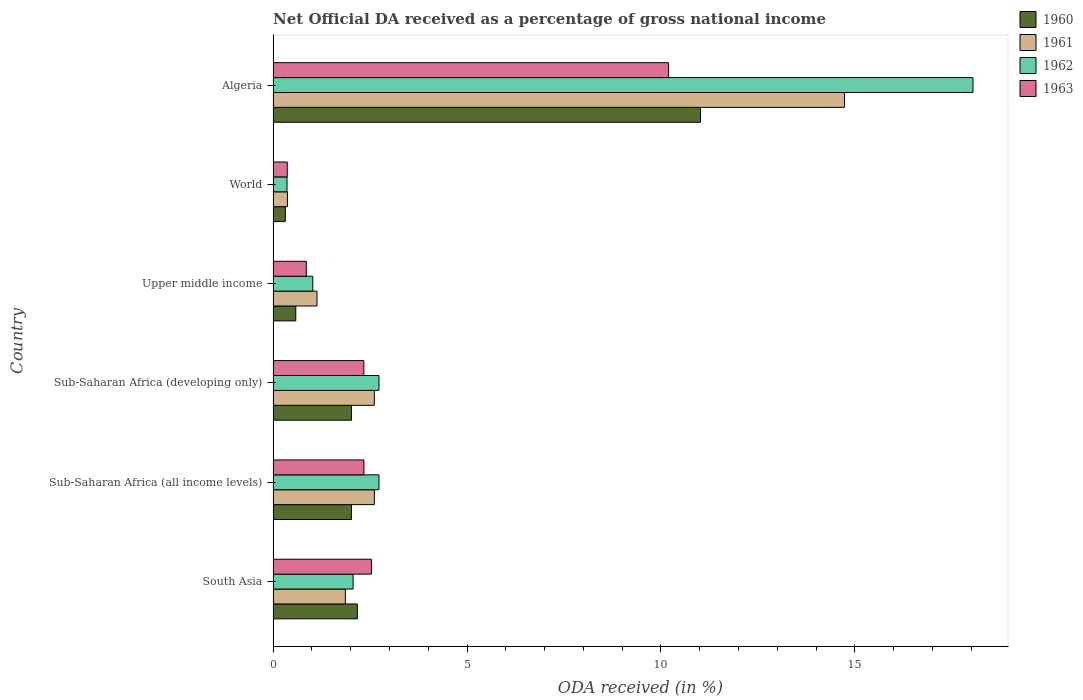Are the number of bars per tick equal to the number of legend labels?
Give a very brief answer. Yes. What is the label of the 2nd group of bars from the top?
Your response must be concise. World. What is the net official DA received in 1960 in World?
Your response must be concise. 0.31. Across all countries, what is the maximum net official DA received in 1961?
Ensure brevity in your answer.  14.73. Across all countries, what is the minimum net official DA received in 1961?
Give a very brief answer. 0.37. In which country was the net official DA received in 1960 maximum?
Give a very brief answer. Algeria. What is the total net official DA received in 1960 in the graph?
Your answer should be very brief. 18.13. What is the difference between the net official DA received in 1960 in Sub-Saharan Africa (developing only) and that in World?
Offer a very short reply. 1.71. What is the difference between the net official DA received in 1962 in World and the net official DA received in 1961 in Upper middle income?
Provide a short and direct response. -0.77. What is the average net official DA received in 1963 per country?
Offer a terse response. 3.11. What is the difference between the net official DA received in 1960 and net official DA received in 1963 in Upper middle income?
Make the answer very short. -0.27. What is the ratio of the net official DA received in 1963 in Algeria to that in World?
Your answer should be compact. 27.96. Is the difference between the net official DA received in 1960 in South Asia and World greater than the difference between the net official DA received in 1963 in South Asia and World?
Your answer should be compact. No. What is the difference between the highest and the second highest net official DA received in 1960?
Your answer should be very brief. 8.85. What is the difference between the highest and the lowest net official DA received in 1961?
Your answer should be very brief. 14.36. Is the sum of the net official DA received in 1962 in Algeria and Upper middle income greater than the maximum net official DA received in 1960 across all countries?
Offer a terse response. Yes. Is it the case that in every country, the sum of the net official DA received in 1961 and net official DA received in 1963 is greater than the sum of net official DA received in 1960 and net official DA received in 1962?
Give a very brief answer. No. What does the 4th bar from the top in Upper middle income represents?
Keep it short and to the point. 1960. Is it the case that in every country, the sum of the net official DA received in 1961 and net official DA received in 1962 is greater than the net official DA received in 1963?
Give a very brief answer. Yes. Are the values on the major ticks of X-axis written in scientific E-notation?
Your response must be concise. No. Does the graph contain any zero values?
Keep it short and to the point. No. Does the graph contain grids?
Offer a very short reply. No. Where does the legend appear in the graph?
Your answer should be very brief. Top right. What is the title of the graph?
Your response must be concise. Net Official DA received as a percentage of gross national income. Does "1970" appear as one of the legend labels in the graph?
Keep it short and to the point. No. What is the label or title of the X-axis?
Make the answer very short. ODA received (in %). What is the label or title of the Y-axis?
Your answer should be very brief. Country. What is the ODA received (in %) in 1960 in South Asia?
Your answer should be very brief. 2.17. What is the ODA received (in %) of 1961 in South Asia?
Your response must be concise. 1.86. What is the ODA received (in %) in 1962 in South Asia?
Your response must be concise. 2.06. What is the ODA received (in %) of 1963 in South Asia?
Keep it short and to the point. 2.53. What is the ODA received (in %) of 1960 in Sub-Saharan Africa (all income levels)?
Your answer should be compact. 2.02. What is the ODA received (in %) of 1961 in Sub-Saharan Africa (all income levels)?
Provide a succinct answer. 2.61. What is the ODA received (in %) of 1962 in Sub-Saharan Africa (all income levels)?
Keep it short and to the point. 2.73. What is the ODA received (in %) of 1963 in Sub-Saharan Africa (all income levels)?
Your response must be concise. 2.34. What is the ODA received (in %) of 1960 in Sub-Saharan Africa (developing only)?
Make the answer very short. 2.02. What is the ODA received (in %) of 1961 in Sub-Saharan Africa (developing only)?
Make the answer very short. 2.61. What is the ODA received (in %) in 1962 in Sub-Saharan Africa (developing only)?
Your response must be concise. 2.73. What is the ODA received (in %) in 1963 in Sub-Saharan Africa (developing only)?
Your answer should be very brief. 2.34. What is the ODA received (in %) of 1960 in Upper middle income?
Ensure brevity in your answer.  0.58. What is the ODA received (in %) of 1961 in Upper middle income?
Your answer should be compact. 1.13. What is the ODA received (in %) of 1962 in Upper middle income?
Give a very brief answer. 1.02. What is the ODA received (in %) of 1963 in Upper middle income?
Give a very brief answer. 0.86. What is the ODA received (in %) of 1960 in World?
Make the answer very short. 0.31. What is the ODA received (in %) of 1961 in World?
Ensure brevity in your answer.  0.37. What is the ODA received (in %) of 1962 in World?
Provide a short and direct response. 0.36. What is the ODA received (in %) of 1963 in World?
Give a very brief answer. 0.36. What is the ODA received (in %) of 1960 in Algeria?
Ensure brevity in your answer.  11.02. What is the ODA received (in %) in 1961 in Algeria?
Your answer should be very brief. 14.73. What is the ODA received (in %) of 1962 in Algeria?
Your answer should be very brief. 18.05. What is the ODA received (in %) in 1963 in Algeria?
Provide a short and direct response. 10.2. Across all countries, what is the maximum ODA received (in %) in 1960?
Offer a very short reply. 11.02. Across all countries, what is the maximum ODA received (in %) in 1961?
Your answer should be compact. 14.73. Across all countries, what is the maximum ODA received (in %) in 1962?
Offer a very short reply. 18.05. Across all countries, what is the maximum ODA received (in %) of 1963?
Provide a short and direct response. 10.2. Across all countries, what is the minimum ODA received (in %) in 1960?
Offer a very short reply. 0.31. Across all countries, what is the minimum ODA received (in %) in 1961?
Offer a very short reply. 0.37. Across all countries, what is the minimum ODA received (in %) in 1962?
Your answer should be compact. 0.36. Across all countries, what is the minimum ODA received (in %) of 1963?
Provide a short and direct response. 0.36. What is the total ODA received (in %) in 1960 in the graph?
Your response must be concise. 18.13. What is the total ODA received (in %) of 1961 in the graph?
Your answer should be very brief. 23.32. What is the total ODA received (in %) in 1962 in the graph?
Keep it short and to the point. 26.95. What is the total ODA received (in %) of 1963 in the graph?
Make the answer very short. 18.63. What is the difference between the ODA received (in %) of 1960 in South Asia and that in Sub-Saharan Africa (all income levels)?
Ensure brevity in your answer.  0.15. What is the difference between the ODA received (in %) in 1961 in South Asia and that in Sub-Saharan Africa (all income levels)?
Offer a terse response. -0.75. What is the difference between the ODA received (in %) of 1962 in South Asia and that in Sub-Saharan Africa (all income levels)?
Provide a short and direct response. -0.67. What is the difference between the ODA received (in %) in 1963 in South Asia and that in Sub-Saharan Africa (all income levels)?
Provide a succinct answer. 0.19. What is the difference between the ODA received (in %) of 1960 in South Asia and that in Sub-Saharan Africa (developing only)?
Your answer should be compact. 0.15. What is the difference between the ODA received (in %) of 1961 in South Asia and that in Sub-Saharan Africa (developing only)?
Ensure brevity in your answer.  -0.75. What is the difference between the ODA received (in %) of 1962 in South Asia and that in Sub-Saharan Africa (developing only)?
Your answer should be compact. -0.67. What is the difference between the ODA received (in %) of 1963 in South Asia and that in Sub-Saharan Africa (developing only)?
Your answer should be compact. 0.19. What is the difference between the ODA received (in %) in 1960 in South Asia and that in Upper middle income?
Your response must be concise. 1.59. What is the difference between the ODA received (in %) of 1961 in South Asia and that in Upper middle income?
Offer a terse response. 0.73. What is the difference between the ODA received (in %) of 1962 in South Asia and that in Upper middle income?
Ensure brevity in your answer.  1.04. What is the difference between the ODA received (in %) of 1963 in South Asia and that in Upper middle income?
Keep it short and to the point. 1.68. What is the difference between the ODA received (in %) of 1960 in South Asia and that in World?
Ensure brevity in your answer.  1.86. What is the difference between the ODA received (in %) in 1961 in South Asia and that in World?
Provide a succinct answer. 1.49. What is the difference between the ODA received (in %) of 1962 in South Asia and that in World?
Ensure brevity in your answer.  1.7. What is the difference between the ODA received (in %) in 1963 in South Asia and that in World?
Offer a very short reply. 2.17. What is the difference between the ODA received (in %) in 1960 in South Asia and that in Algeria?
Offer a terse response. -8.85. What is the difference between the ODA received (in %) in 1961 in South Asia and that in Algeria?
Give a very brief answer. -12.87. What is the difference between the ODA received (in %) of 1962 in South Asia and that in Algeria?
Ensure brevity in your answer.  -15.99. What is the difference between the ODA received (in %) of 1963 in South Asia and that in Algeria?
Ensure brevity in your answer.  -7.66. What is the difference between the ODA received (in %) of 1960 in Sub-Saharan Africa (all income levels) and that in Sub-Saharan Africa (developing only)?
Your answer should be very brief. 0. What is the difference between the ODA received (in %) in 1961 in Sub-Saharan Africa (all income levels) and that in Sub-Saharan Africa (developing only)?
Keep it short and to the point. 0. What is the difference between the ODA received (in %) of 1962 in Sub-Saharan Africa (all income levels) and that in Sub-Saharan Africa (developing only)?
Provide a short and direct response. 0. What is the difference between the ODA received (in %) of 1963 in Sub-Saharan Africa (all income levels) and that in Sub-Saharan Africa (developing only)?
Your answer should be compact. 0. What is the difference between the ODA received (in %) in 1960 in Sub-Saharan Africa (all income levels) and that in Upper middle income?
Provide a short and direct response. 1.44. What is the difference between the ODA received (in %) in 1961 in Sub-Saharan Africa (all income levels) and that in Upper middle income?
Offer a terse response. 1.48. What is the difference between the ODA received (in %) of 1962 in Sub-Saharan Africa (all income levels) and that in Upper middle income?
Keep it short and to the point. 1.71. What is the difference between the ODA received (in %) in 1963 in Sub-Saharan Africa (all income levels) and that in Upper middle income?
Your response must be concise. 1.49. What is the difference between the ODA received (in %) of 1960 in Sub-Saharan Africa (all income levels) and that in World?
Provide a succinct answer. 1.71. What is the difference between the ODA received (in %) in 1961 in Sub-Saharan Africa (all income levels) and that in World?
Your answer should be very brief. 2.24. What is the difference between the ODA received (in %) of 1962 in Sub-Saharan Africa (all income levels) and that in World?
Offer a very short reply. 2.37. What is the difference between the ODA received (in %) in 1963 in Sub-Saharan Africa (all income levels) and that in World?
Offer a terse response. 1.98. What is the difference between the ODA received (in %) in 1960 in Sub-Saharan Africa (all income levels) and that in Algeria?
Offer a very short reply. -9. What is the difference between the ODA received (in %) of 1961 in Sub-Saharan Africa (all income levels) and that in Algeria?
Provide a succinct answer. -12.12. What is the difference between the ODA received (in %) in 1962 in Sub-Saharan Africa (all income levels) and that in Algeria?
Your answer should be very brief. -15.32. What is the difference between the ODA received (in %) in 1963 in Sub-Saharan Africa (all income levels) and that in Algeria?
Your answer should be compact. -7.86. What is the difference between the ODA received (in %) in 1960 in Sub-Saharan Africa (developing only) and that in Upper middle income?
Offer a terse response. 1.44. What is the difference between the ODA received (in %) of 1961 in Sub-Saharan Africa (developing only) and that in Upper middle income?
Provide a succinct answer. 1.48. What is the difference between the ODA received (in %) of 1962 in Sub-Saharan Africa (developing only) and that in Upper middle income?
Your answer should be very brief. 1.71. What is the difference between the ODA received (in %) in 1963 in Sub-Saharan Africa (developing only) and that in Upper middle income?
Your answer should be very brief. 1.49. What is the difference between the ODA received (in %) in 1960 in Sub-Saharan Africa (developing only) and that in World?
Keep it short and to the point. 1.71. What is the difference between the ODA received (in %) in 1961 in Sub-Saharan Africa (developing only) and that in World?
Ensure brevity in your answer.  2.24. What is the difference between the ODA received (in %) of 1962 in Sub-Saharan Africa (developing only) and that in World?
Make the answer very short. 2.37. What is the difference between the ODA received (in %) in 1963 in Sub-Saharan Africa (developing only) and that in World?
Your answer should be very brief. 1.98. What is the difference between the ODA received (in %) in 1960 in Sub-Saharan Africa (developing only) and that in Algeria?
Offer a terse response. -9. What is the difference between the ODA received (in %) in 1961 in Sub-Saharan Africa (developing only) and that in Algeria?
Keep it short and to the point. -12.12. What is the difference between the ODA received (in %) of 1962 in Sub-Saharan Africa (developing only) and that in Algeria?
Offer a very short reply. -15.32. What is the difference between the ODA received (in %) in 1963 in Sub-Saharan Africa (developing only) and that in Algeria?
Offer a terse response. -7.86. What is the difference between the ODA received (in %) of 1960 in Upper middle income and that in World?
Your answer should be very brief. 0.27. What is the difference between the ODA received (in %) in 1961 in Upper middle income and that in World?
Keep it short and to the point. 0.76. What is the difference between the ODA received (in %) of 1962 in Upper middle income and that in World?
Provide a short and direct response. 0.66. What is the difference between the ODA received (in %) in 1963 in Upper middle income and that in World?
Ensure brevity in your answer.  0.49. What is the difference between the ODA received (in %) of 1960 in Upper middle income and that in Algeria?
Make the answer very short. -10.44. What is the difference between the ODA received (in %) of 1961 in Upper middle income and that in Algeria?
Provide a succinct answer. -13.6. What is the difference between the ODA received (in %) in 1962 in Upper middle income and that in Algeria?
Keep it short and to the point. -17.03. What is the difference between the ODA received (in %) in 1963 in Upper middle income and that in Algeria?
Give a very brief answer. -9.34. What is the difference between the ODA received (in %) in 1960 in World and that in Algeria?
Give a very brief answer. -10.71. What is the difference between the ODA received (in %) in 1961 in World and that in Algeria?
Your response must be concise. -14.36. What is the difference between the ODA received (in %) of 1962 in World and that in Algeria?
Offer a terse response. -17.69. What is the difference between the ODA received (in %) in 1963 in World and that in Algeria?
Provide a short and direct response. -9.83. What is the difference between the ODA received (in %) of 1960 in South Asia and the ODA received (in %) of 1961 in Sub-Saharan Africa (all income levels)?
Your response must be concise. -0.44. What is the difference between the ODA received (in %) of 1960 in South Asia and the ODA received (in %) of 1962 in Sub-Saharan Africa (all income levels)?
Your answer should be compact. -0.56. What is the difference between the ODA received (in %) of 1960 in South Asia and the ODA received (in %) of 1963 in Sub-Saharan Africa (all income levels)?
Provide a short and direct response. -0.17. What is the difference between the ODA received (in %) of 1961 in South Asia and the ODA received (in %) of 1962 in Sub-Saharan Africa (all income levels)?
Offer a very short reply. -0.87. What is the difference between the ODA received (in %) of 1961 in South Asia and the ODA received (in %) of 1963 in Sub-Saharan Africa (all income levels)?
Keep it short and to the point. -0.48. What is the difference between the ODA received (in %) of 1962 in South Asia and the ODA received (in %) of 1963 in Sub-Saharan Africa (all income levels)?
Your answer should be compact. -0.28. What is the difference between the ODA received (in %) of 1960 in South Asia and the ODA received (in %) of 1961 in Sub-Saharan Africa (developing only)?
Provide a short and direct response. -0.44. What is the difference between the ODA received (in %) of 1960 in South Asia and the ODA received (in %) of 1962 in Sub-Saharan Africa (developing only)?
Keep it short and to the point. -0.56. What is the difference between the ODA received (in %) of 1960 in South Asia and the ODA received (in %) of 1963 in Sub-Saharan Africa (developing only)?
Ensure brevity in your answer.  -0.17. What is the difference between the ODA received (in %) of 1961 in South Asia and the ODA received (in %) of 1962 in Sub-Saharan Africa (developing only)?
Offer a terse response. -0.87. What is the difference between the ODA received (in %) of 1961 in South Asia and the ODA received (in %) of 1963 in Sub-Saharan Africa (developing only)?
Provide a short and direct response. -0.48. What is the difference between the ODA received (in %) in 1962 in South Asia and the ODA received (in %) in 1963 in Sub-Saharan Africa (developing only)?
Offer a terse response. -0.28. What is the difference between the ODA received (in %) in 1960 in South Asia and the ODA received (in %) in 1961 in Upper middle income?
Give a very brief answer. 1.04. What is the difference between the ODA received (in %) in 1960 in South Asia and the ODA received (in %) in 1962 in Upper middle income?
Provide a succinct answer. 1.15. What is the difference between the ODA received (in %) in 1960 in South Asia and the ODA received (in %) in 1963 in Upper middle income?
Your answer should be compact. 1.32. What is the difference between the ODA received (in %) of 1961 in South Asia and the ODA received (in %) of 1962 in Upper middle income?
Your response must be concise. 0.84. What is the difference between the ODA received (in %) of 1961 in South Asia and the ODA received (in %) of 1963 in Upper middle income?
Keep it short and to the point. 1.01. What is the difference between the ODA received (in %) in 1962 in South Asia and the ODA received (in %) in 1963 in Upper middle income?
Provide a short and direct response. 1.21. What is the difference between the ODA received (in %) in 1960 in South Asia and the ODA received (in %) in 1961 in World?
Make the answer very short. 1.8. What is the difference between the ODA received (in %) in 1960 in South Asia and the ODA received (in %) in 1962 in World?
Your answer should be very brief. 1.81. What is the difference between the ODA received (in %) of 1960 in South Asia and the ODA received (in %) of 1963 in World?
Your response must be concise. 1.81. What is the difference between the ODA received (in %) in 1961 in South Asia and the ODA received (in %) in 1962 in World?
Provide a succinct answer. 1.5. What is the difference between the ODA received (in %) of 1961 in South Asia and the ODA received (in %) of 1963 in World?
Your answer should be very brief. 1.5. What is the difference between the ODA received (in %) of 1962 in South Asia and the ODA received (in %) of 1963 in World?
Provide a short and direct response. 1.7. What is the difference between the ODA received (in %) in 1960 in South Asia and the ODA received (in %) in 1961 in Algeria?
Your answer should be compact. -12.56. What is the difference between the ODA received (in %) in 1960 in South Asia and the ODA received (in %) in 1962 in Algeria?
Your answer should be compact. -15.88. What is the difference between the ODA received (in %) in 1960 in South Asia and the ODA received (in %) in 1963 in Algeria?
Offer a very short reply. -8.03. What is the difference between the ODA received (in %) in 1961 in South Asia and the ODA received (in %) in 1962 in Algeria?
Your response must be concise. -16.19. What is the difference between the ODA received (in %) of 1961 in South Asia and the ODA received (in %) of 1963 in Algeria?
Ensure brevity in your answer.  -8.34. What is the difference between the ODA received (in %) of 1962 in South Asia and the ODA received (in %) of 1963 in Algeria?
Ensure brevity in your answer.  -8.14. What is the difference between the ODA received (in %) of 1960 in Sub-Saharan Africa (all income levels) and the ODA received (in %) of 1961 in Sub-Saharan Africa (developing only)?
Your answer should be very brief. -0.59. What is the difference between the ODA received (in %) of 1960 in Sub-Saharan Africa (all income levels) and the ODA received (in %) of 1962 in Sub-Saharan Africa (developing only)?
Keep it short and to the point. -0.71. What is the difference between the ODA received (in %) of 1960 in Sub-Saharan Africa (all income levels) and the ODA received (in %) of 1963 in Sub-Saharan Africa (developing only)?
Your answer should be very brief. -0.32. What is the difference between the ODA received (in %) in 1961 in Sub-Saharan Africa (all income levels) and the ODA received (in %) in 1962 in Sub-Saharan Africa (developing only)?
Ensure brevity in your answer.  -0.12. What is the difference between the ODA received (in %) of 1961 in Sub-Saharan Africa (all income levels) and the ODA received (in %) of 1963 in Sub-Saharan Africa (developing only)?
Your response must be concise. 0.27. What is the difference between the ODA received (in %) of 1962 in Sub-Saharan Africa (all income levels) and the ODA received (in %) of 1963 in Sub-Saharan Africa (developing only)?
Your answer should be very brief. 0.39. What is the difference between the ODA received (in %) of 1960 in Sub-Saharan Africa (all income levels) and the ODA received (in %) of 1961 in Upper middle income?
Keep it short and to the point. 0.89. What is the difference between the ODA received (in %) of 1960 in Sub-Saharan Africa (all income levels) and the ODA received (in %) of 1962 in Upper middle income?
Give a very brief answer. 1. What is the difference between the ODA received (in %) in 1960 in Sub-Saharan Africa (all income levels) and the ODA received (in %) in 1963 in Upper middle income?
Make the answer very short. 1.17. What is the difference between the ODA received (in %) in 1961 in Sub-Saharan Africa (all income levels) and the ODA received (in %) in 1962 in Upper middle income?
Provide a succinct answer. 1.59. What is the difference between the ODA received (in %) of 1961 in Sub-Saharan Africa (all income levels) and the ODA received (in %) of 1963 in Upper middle income?
Your response must be concise. 1.76. What is the difference between the ODA received (in %) of 1962 in Sub-Saharan Africa (all income levels) and the ODA received (in %) of 1963 in Upper middle income?
Offer a very short reply. 1.87. What is the difference between the ODA received (in %) in 1960 in Sub-Saharan Africa (all income levels) and the ODA received (in %) in 1961 in World?
Your answer should be compact. 1.65. What is the difference between the ODA received (in %) in 1960 in Sub-Saharan Africa (all income levels) and the ODA received (in %) in 1962 in World?
Provide a succinct answer. 1.66. What is the difference between the ODA received (in %) of 1960 in Sub-Saharan Africa (all income levels) and the ODA received (in %) of 1963 in World?
Provide a succinct answer. 1.66. What is the difference between the ODA received (in %) in 1961 in Sub-Saharan Africa (all income levels) and the ODA received (in %) in 1962 in World?
Ensure brevity in your answer.  2.25. What is the difference between the ODA received (in %) in 1961 in Sub-Saharan Africa (all income levels) and the ODA received (in %) in 1963 in World?
Ensure brevity in your answer.  2.25. What is the difference between the ODA received (in %) of 1962 in Sub-Saharan Africa (all income levels) and the ODA received (in %) of 1963 in World?
Keep it short and to the point. 2.37. What is the difference between the ODA received (in %) of 1960 in Sub-Saharan Africa (all income levels) and the ODA received (in %) of 1961 in Algeria?
Ensure brevity in your answer.  -12.71. What is the difference between the ODA received (in %) of 1960 in Sub-Saharan Africa (all income levels) and the ODA received (in %) of 1962 in Algeria?
Offer a very short reply. -16.03. What is the difference between the ODA received (in %) in 1960 in Sub-Saharan Africa (all income levels) and the ODA received (in %) in 1963 in Algeria?
Your answer should be very brief. -8.18. What is the difference between the ODA received (in %) in 1961 in Sub-Saharan Africa (all income levels) and the ODA received (in %) in 1962 in Algeria?
Give a very brief answer. -15.44. What is the difference between the ODA received (in %) of 1961 in Sub-Saharan Africa (all income levels) and the ODA received (in %) of 1963 in Algeria?
Provide a short and direct response. -7.59. What is the difference between the ODA received (in %) of 1962 in Sub-Saharan Africa (all income levels) and the ODA received (in %) of 1963 in Algeria?
Make the answer very short. -7.47. What is the difference between the ODA received (in %) in 1960 in Sub-Saharan Africa (developing only) and the ODA received (in %) in 1961 in Upper middle income?
Ensure brevity in your answer.  0.89. What is the difference between the ODA received (in %) in 1960 in Sub-Saharan Africa (developing only) and the ODA received (in %) in 1963 in Upper middle income?
Offer a terse response. 1.17. What is the difference between the ODA received (in %) of 1961 in Sub-Saharan Africa (developing only) and the ODA received (in %) of 1962 in Upper middle income?
Offer a terse response. 1.59. What is the difference between the ODA received (in %) in 1961 in Sub-Saharan Africa (developing only) and the ODA received (in %) in 1963 in Upper middle income?
Offer a very short reply. 1.75. What is the difference between the ODA received (in %) in 1962 in Sub-Saharan Africa (developing only) and the ODA received (in %) in 1963 in Upper middle income?
Ensure brevity in your answer.  1.87. What is the difference between the ODA received (in %) in 1960 in Sub-Saharan Africa (developing only) and the ODA received (in %) in 1961 in World?
Your response must be concise. 1.65. What is the difference between the ODA received (in %) in 1960 in Sub-Saharan Africa (developing only) and the ODA received (in %) in 1962 in World?
Offer a very short reply. 1.66. What is the difference between the ODA received (in %) in 1960 in Sub-Saharan Africa (developing only) and the ODA received (in %) in 1963 in World?
Your answer should be very brief. 1.66. What is the difference between the ODA received (in %) in 1961 in Sub-Saharan Africa (developing only) and the ODA received (in %) in 1962 in World?
Offer a very short reply. 2.25. What is the difference between the ODA received (in %) in 1961 in Sub-Saharan Africa (developing only) and the ODA received (in %) in 1963 in World?
Your answer should be compact. 2.25. What is the difference between the ODA received (in %) in 1962 in Sub-Saharan Africa (developing only) and the ODA received (in %) in 1963 in World?
Give a very brief answer. 2.36. What is the difference between the ODA received (in %) in 1960 in Sub-Saharan Africa (developing only) and the ODA received (in %) in 1961 in Algeria?
Your answer should be compact. -12.71. What is the difference between the ODA received (in %) of 1960 in Sub-Saharan Africa (developing only) and the ODA received (in %) of 1962 in Algeria?
Give a very brief answer. -16.03. What is the difference between the ODA received (in %) in 1960 in Sub-Saharan Africa (developing only) and the ODA received (in %) in 1963 in Algeria?
Provide a succinct answer. -8.18. What is the difference between the ODA received (in %) in 1961 in Sub-Saharan Africa (developing only) and the ODA received (in %) in 1962 in Algeria?
Keep it short and to the point. -15.44. What is the difference between the ODA received (in %) in 1961 in Sub-Saharan Africa (developing only) and the ODA received (in %) in 1963 in Algeria?
Ensure brevity in your answer.  -7.59. What is the difference between the ODA received (in %) of 1962 in Sub-Saharan Africa (developing only) and the ODA received (in %) of 1963 in Algeria?
Provide a succinct answer. -7.47. What is the difference between the ODA received (in %) of 1960 in Upper middle income and the ODA received (in %) of 1961 in World?
Your answer should be compact. 0.21. What is the difference between the ODA received (in %) of 1960 in Upper middle income and the ODA received (in %) of 1962 in World?
Keep it short and to the point. 0.23. What is the difference between the ODA received (in %) in 1960 in Upper middle income and the ODA received (in %) in 1963 in World?
Your answer should be very brief. 0.22. What is the difference between the ODA received (in %) of 1961 in Upper middle income and the ODA received (in %) of 1962 in World?
Offer a terse response. 0.77. What is the difference between the ODA received (in %) of 1961 in Upper middle income and the ODA received (in %) of 1963 in World?
Your answer should be very brief. 0.77. What is the difference between the ODA received (in %) in 1962 in Upper middle income and the ODA received (in %) in 1963 in World?
Your answer should be compact. 0.66. What is the difference between the ODA received (in %) of 1960 in Upper middle income and the ODA received (in %) of 1961 in Algeria?
Ensure brevity in your answer.  -14.15. What is the difference between the ODA received (in %) in 1960 in Upper middle income and the ODA received (in %) in 1962 in Algeria?
Your response must be concise. -17.46. What is the difference between the ODA received (in %) in 1960 in Upper middle income and the ODA received (in %) in 1963 in Algeria?
Ensure brevity in your answer.  -9.61. What is the difference between the ODA received (in %) in 1961 in Upper middle income and the ODA received (in %) in 1962 in Algeria?
Offer a terse response. -16.92. What is the difference between the ODA received (in %) of 1961 in Upper middle income and the ODA received (in %) of 1963 in Algeria?
Make the answer very short. -9.07. What is the difference between the ODA received (in %) of 1962 in Upper middle income and the ODA received (in %) of 1963 in Algeria?
Give a very brief answer. -9.18. What is the difference between the ODA received (in %) of 1960 in World and the ODA received (in %) of 1961 in Algeria?
Offer a terse response. -14.42. What is the difference between the ODA received (in %) in 1960 in World and the ODA received (in %) in 1962 in Algeria?
Offer a terse response. -17.73. What is the difference between the ODA received (in %) in 1960 in World and the ODA received (in %) in 1963 in Algeria?
Offer a very short reply. -9.88. What is the difference between the ODA received (in %) of 1961 in World and the ODA received (in %) of 1962 in Algeria?
Give a very brief answer. -17.68. What is the difference between the ODA received (in %) in 1961 in World and the ODA received (in %) in 1963 in Algeria?
Offer a terse response. -9.83. What is the difference between the ODA received (in %) of 1962 in World and the ODA received (in %) of 1963 in Algeria?
Make the answer very short. -9.84. What is the average ODA received (in %) in 1960 per country?
Keep it short and to the point. 3.02. What is the average ODA received (in %) in 1961 per country?
Give a very brief answer. 3.89. What is the average ODA received (in %) of 1962 per country?
Provide a succinct answer. 4.49. What is the average ODA received (in %) of 1963 per country?
Keep it short and to the point. 3.11. What is the difference between the ODA received (in %) of 1960 and ODA received (in %) of 1961 in South Asia?
Provide a succinct answer. 0.31. What is the difference between the ODA received (in %) of 1960 and ODA received (in %) of 1962 in South Asia?
Give a very brief answer. 0.11. What is the difference between the ODA received (in %) in 1960 and ODA received (in %) in 1963 in South Asia?
Ensure brevity in your answer.  -0.36. What is the difference between the ODA received (in %) of 1961 and ODA received (in %) of 1962 in South Asia?
Ensure brevity in your answer.  -0.2. What is the difference between the ODA received (in %) of 1961 and ODA received (in %) of 1963 in South Asia?
Offer a terse response. -0.67. What is the difference between the ODA received (in %) of 1962 and ODA received (in %) of 1963 in South Asia?
Keep it short and to the point. -0.47. What is the difference between the ODA received (in %) of 1960 and ODA received (in %) of 1961 in Sub-Saharan Africa (all income levels)?
Your response must be concise. -0.59. What is the difference between the ODA received (in %) of 1960 and ODA received (in %) of 1962 in Sub-Saharan Africa (all income levels)?
Offer a very short reply. -0.71. What is the difference between the ODA received (in %) of 1960 and ODA received (in %) of 1963 in Sub-Saharan Africa (all income levels)?
Provide a short and direct response. -0.32. What is the difference between the ODA received (in %) in 1961 and ODA received (in %) in 1962 in Sub-Saharan Africa (all income levels)?
Provide a short and direct response. -0.12. What is the difference between the ODA received (in %) in 1961 and ODA received (in %) in 1963 in Sub-Saharan Africa (all income levels)?
Make the answer very short. 0.27. What is the difference between the ODA received (in %) of 1962 and ODA received (in %) of 1963 in Sub-Saharan Africa (all income levels)?
Offer a terse response. 0.39. What is the difference between the ODA received (in %) in 1960 and ODA received (in %) in 1961 in Sub-Saharan Africa (developing only)?
Offer a terse response. -0.59. What is the difference between the ODA received (in %) in 1960 and ODA received (in %) in 1962 in Sub-Saharan Africa (developing only)?
Make the answer very short. -0.71. What is the difference between the ODA received (in %) of 1960 and ODA received (in %) of 1963 in Sub-Saharan Africa (developing only)?
Offer a very short reply. -0.32. What is the difference between the ODA received (in %) in 1961 and ODA received (in %) in 1962 in Sub-Saharan Africa (developing only)?
Make the answer very short. -0.12. What is the difference between the ODA received (in %) of 1961 and ODA received (in %) of 1963 in Sub-Saharan Africa (developing only)?
Give a very brief answer. 0.27. What is the difference between the ODA received (in %) of 1962 and ODA received (in %) of 1963 in Sub-Saharan Africa (developing only)?
Give a very brief answer. 0.39. What is the difference between the ODA received (in %) of 1960 and ODA received (in %) of 1961 in Upper middle income?
Your answer should be compact. -0.55. What is the difference between the ODA received (in %) of 1960 and ODA received (in %) of 1962 in Upper middle income?
Offer a terse response. -0.44. What is the difference between the ODA received (in %) of 1960 and ODA received (in %) of 1963 in Upper middle income?
Your answer should be very brief. -0.27. What is the difference between the ODA received (in %) in 1961 and ODA received (in %) in 1962 in Upper middle income?
Give a very brief answer. 0.11. What is the difference between the ODA received (in %) in 1961 and ODA received (in %) in 1963 in Upper middle income?
Your answer should be very brief. 0.28. What is the difference between the ODA received (in %) of 1962 and ODA received (in %) of 1963 in Upper middle income?
Offer a very short reply. 0.17. What is the difference between the ODA received (in %) in 1960 and ODA received (in %) in 1961 in World?
Offer a very short reply. -0.06. What is the difference between the ODA received (in %) in 1960 and ODA received (in %) in 1962 in World?
Ensure brevity in your answer.  -0.04. What is the difference between the ODA received (in %) of 1960 and ODA received (in %) of 1963 in World?
Offer a very short reply. -0.05. What is the difference between the ODA received (in %) of 1961 and ODA received (in %) of 1962 in World?
Make the answer very short. 0.01. What is the difference between the ODA received (in %) of 1961 and ODA received (in %) of 1963 in World?
Keep it short and to the point. 0. What is the difference between the ODA received (in %) of 1962 and ODA received (in %) of 1963 in World?
Your answer should be very brief. -0.01. What is the difference between the ODA received (in %) of 1960 and ODA received (in %) of 1961 in Algeria?
Your answer should be compact. -3.71. What is the difference between the ODA received (in %) of 1960 and ODA received (in %) of 1962 in Algeria?
Offer a terse response. -7.03. What is the difference between the ODA received (in %) in 1960 and ODA received (in %) in 1963 in Algeria?
Make the answer very short. 0.82. What is the difference between the ODA received (in %) of 1961 and ODA received (in %) of 1962 in Algeria?
Offer a terse response. -3.31. What is the difference between the ODA received (in %) in 1961 and ODA received (in %) in 1963 in Algeria?
Offer a very short reply. 4.54. What is the difference between the ODA received (in %) in 1962 and ODA received (in %) in 1963 in Algeria?
Offer a very short reply. 7.85. What is the ratio of the ODA received (in %) in 1960 in South Asia to that in Sub-Saharan Africa (all income levels)?
Keep it short and to the point. 1.07. What is the ratio of the ODA received (in %) of 1961 in South Asia to that in Sub-Saharan Africa (all income levels)?
Your answer should be compact. 0.71. What is the ratio of the ODA received (in %) in 1962 in South Asia to that in Sub-Saharan Africa (all income levels)?
Provide a short and direct response. 0.76. What is the ratio of the ODA received (in %) in 1963 in South Asia to that in Sub-Saharan Africa (all income levels)?
Your answer should be compact. 1.08. What is the ratio of the ODA received (in %) in 1960 in South Asia to that in Sub-Saharan Africa (developing only)?
Make the answer very short. 1.07. What is the ratio of the ODA received (in %) in 1961 in South Asia to that in Sub-Saharan Africa (developing only)?
Give a very brief answer. 0.71. What is the ratio of the ODA received (in %) in 1962 in South Asia to that in Sub-Saharan Africa (developing only)?
Offer a terse response. 0.76. What is the ratio of the ODA received (in %) of 1963 in South Asia to that in Sub-Saharan Africa (developing only)?
Your answer should be compact. 1.08. What is the ratio of the ODA received (in %) of 1960 in South Asia to that in Upper middle income?
Your answer should be very brief. 3.72. What is the ratio of the ODA received (in %) of 1961 in South Asia to that in Upper middle income?
Keep it short and to the point. 1.65. What is the ratio of the ODA received (in %) in 1962 in South Asia to that in Upper middle income?
Your answer should be very brief. 2.02. What is the ratio of the ODA received (in %) in 1963 in South Asia to that in Upper middle income?
Offer a terse response. 2.96. What is the ratio of the ODA received (in %) of 1960 in South Asia to that in World?
Offer a very short reply. 6.9. What is the ratio of the ODA received (in %) in 1961 in South Asia to that in World?
Provide a short and direct response. 5.04. What is the ratio of the ODA received (in %) in 1962 in South Asia to that in World?
Make the answer very short. 5.76. What is the ratio of the ODA received (in %) in 1963 in South Asia to that in World?
Provide a short and direct response. 6.95. What is the ratio of the ODA received (in %) of 1960 in South Asia to that in Algeria?
Keep it short and to the point. 0.2. What is the ratio of the ODA received (in %) of 1961 in South Asia to that in Algeria?
Provide a succinct answer. 0.13. What is the ratio of the ODA received (in %) of 1962 in South Asia to that in Algeria?
Give a very brief answer. 0.11. What is the ratio of the ODA received (in %) of 1963 in South Asia to that in Algeria?
Your answer should be compact. 0.25. What is the ratio of the ODA received (in %) of 1961 in Sub-Saharan Africa (all income levels) to that in Sub-Saharan Africa (developing only)?
Offer a terse response. 1. What is the ratio of the ODA received (in %) of 1960 in Sub-Saharan Africa (all income levels) to that in Upper middle income?
Provide a short and direct response. 3.46. What is the ratio of the ODA received (in %) of 1961 in Sub-Saharan Africa (all income levels) to that in Upper middle income?
Ensure brevity in your answer.  2.31. What is the ratio of the ODA received (in %) of 1962 in Sub-Saharan Africa (all income levels) to that in Upper middle income?
Your response must be concise. 2.67. What is the ratio of the ODA received (in %) of 1963 in Sub-Saharan Africa (all income levels) to that in Upper middle income?
Provide a short and direct response. 2.74. What is the ratio of the ODA received (in %) in 1960 in Sub-Saharan Africa (all income levels) to that in World?
Your answer should be very brief. 6.43. What is the ratio of the ODA received (in %) in 1961 in Sub-Saharan Africa (all income levels) to that in World?
Make the answer very short. 7.07. What is the ratio of the ODA received (in %) in 1962 in Sub-Saharan Africa (all income levels) to that in World?
Keep it short and to the point. 7.62. What is the ratio of the ODA received (in %) of 1963 in Sub-Saharan Africa (all income levels) to that in World?
Keep it short and to the point. 6.42. What is the ratio of the ODA received (in %) of 1960 in Sub-Saharan Africa (all income levels) to that in Algeria?
Your answer should be compact. 0.18. What is the ratio of the ODA received (in %) of 1961 in Sub-Saharan Africa (all income levels) to that in Algeria?
Offer a terse response. 0.18. What is the ratio of the ODA received (in %) in 1962 in Sub-Saharan Africa (all income levels) to that in Algeria?
Your answer should be very brief. 0.15. What is the ratio of the ODA received (in %) in 1963 in Sub-Saharan Africa (all income levels) to that in Algeria?
Your answer should be compact. 0.23. What is the ratio of the ODA received (in %) of 1960 in Sub-Saharan Africa (developing only) to that in Upper middle income?
Make the answer very short. 3.46. What is the ratio of the ODA received (in %) of 1961 in Sub-Saharan Africa (developing only) to that in Upper middle income?
Give a very brief answer. 2.31. What is the ratio of the ODA received (in %) in 1962 in Sub-Saharan Africa (developing only) to that in Upper middle income?
Offer a terse response. 2.67. What is the ratio of the ODA received (in %) of 1963 in Sub-Saharan Africa (developing only) to that in Upper middle income?
Offer a very short reply. 2.74. What is the ratio of the ODA received (in %) of 1960 in Sub-Saharan Africa (developing only) to that in World?
Provide a short and direct response. 6.43. What is the ratio of the ODA received (in %) in 1961 in Sub-Saharan Africa (developing only) to that in World?
Offer a terse response. 7.06. What is the ratio of the ODA received (in %) in 1962 in Sub-Saharan Africa (developing only) to that in World?
Offer a very short reply. 7.62. What is the ratio of the ODA received (in %) of 1963 in Sub-Saharan Africa (developing only) to that in World?
Your answer should be very brief. 6.42. What is the ratio of the ODA received (in %) in 1960 in Sub-Saharan Africa (developing only) to that in Algeria?
Your response must be concise. 0.18. What is the ratio of the ODA received (in %) in 1961 in Sub-Saharan Africa (developing only) to that in Algeria?
Your answer should be compact. 0.18. What is the ratio of the ODA received (in %) of 1962 in Sub-Saharan Africa (developing only) to that in Algeria?
Your answer should be very brief. 0.15. What is the ratio of the ODA received (in %) in 1963 in Sub-Saharan Africa (developing only) to that in Algeria?
Keep it short and to the point. 0.23. What is the ratio of the ODA received (in %) in 1960 in Upper middle income to that in World?
Your answer should be compact. 1.86. What is the ratio of the ODA received (in %) of 1961 in Upper middle income to that in World?
Your answer should be very brief. 3.06. What is the ratio of the ODA received (in %) in 1962 in Upper middle income to that in World?
Offer a terse response. 2.85. What is the ratio of the ODA received (in %) of 1963 in Upper middle income to that in World?
Keep it short and to the point. 2.34. What is the ratio of the ODA received (in %) in 1960 in Upper middle income to that in Algeria?
Provide a succinct answer. 0.05. What is the ratio of the ODA received (in %) of 1961 in Upper middle income to that in Algeria?
Provide a succinct answer. 0.08. What is the ratio of the ODA received (in %) of 1962 in Upper middle income to that in Algeria?
Your response must be concise. 0.06. What is the ratio of the ODA received (in %) of 1963 in Upper middle income to that in Algeria?
Give a very brief answer. 0.08. What is the ratio of the ODA received (in %) in 1960 in World to that in Algeria?
Your answer should be compact. 0.03. What is the ratio of the ODA received (in %) of 1961 in World to that in Algeria?
Offer a terse response. 0.03. What is the ratio of the ODA received (in %) in 1962 in World to that in Algeria?
Give a very brief answer. 0.02. What is the ratio of the ODA received (in %) of 1963 in World to that in Algeria?
Offer a terse response. 0.04. What is the difference between the highest and the second highest ODA received (in %) of 1960?
Provide a succinct answer. 8.85. What is the difference between the highest and the second highest ODA received (in %) in 1961?
Provide a succinct answer. 12.12. What is the difference between the highest and the second highest ODA received (in %) of 1962?
Keep it short and to the point. 15.32. What is the difference between the highest and the second highest ODA received (in %) of 1963?
Make the answer very short. 7.66. What is the difference between the highest and the lowest ODA received (in %) in 1960?
Provide a short and direct response. 10.71. What is the difference between the highest and the lowest ODA received (in %) in 1961?
Ensure brevity in your answer.  14.36. What is the difference between the highest and the lowest ODA received (in %) in 1962?
Provide a succinct answer. 17.69. What is the difference between the highest and the lowest ODA received (in %) in 1963?
Ensure brevity in your answer.  9.83. 